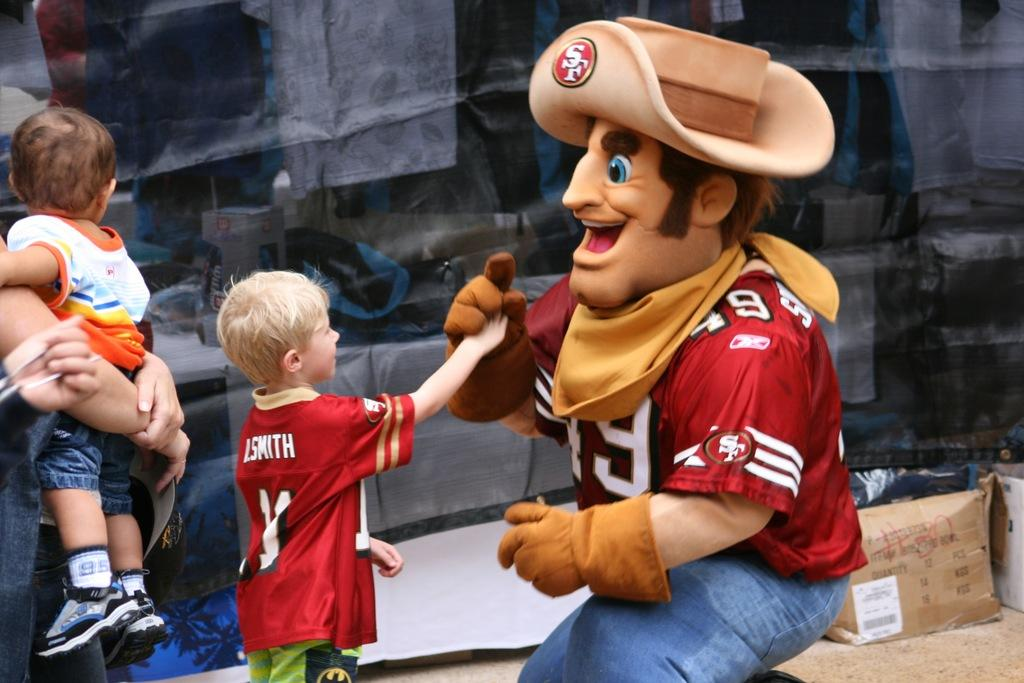Provide a one-sentence caption for the provided image. a mascot that has the SF logo on his hat. 